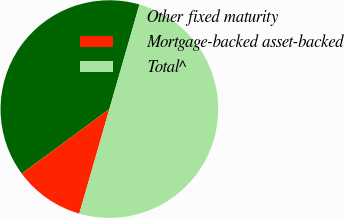<chart> <loc_0><loc_0><loc_500><loc_500><pie_chart><fcel>Other fixed maturity<fcel>Mortgage-backed asset-backed<fcel>Total^<nl><fcel>39.56%<fcel>10.44%<fcel>50.0%<nl></chart> 